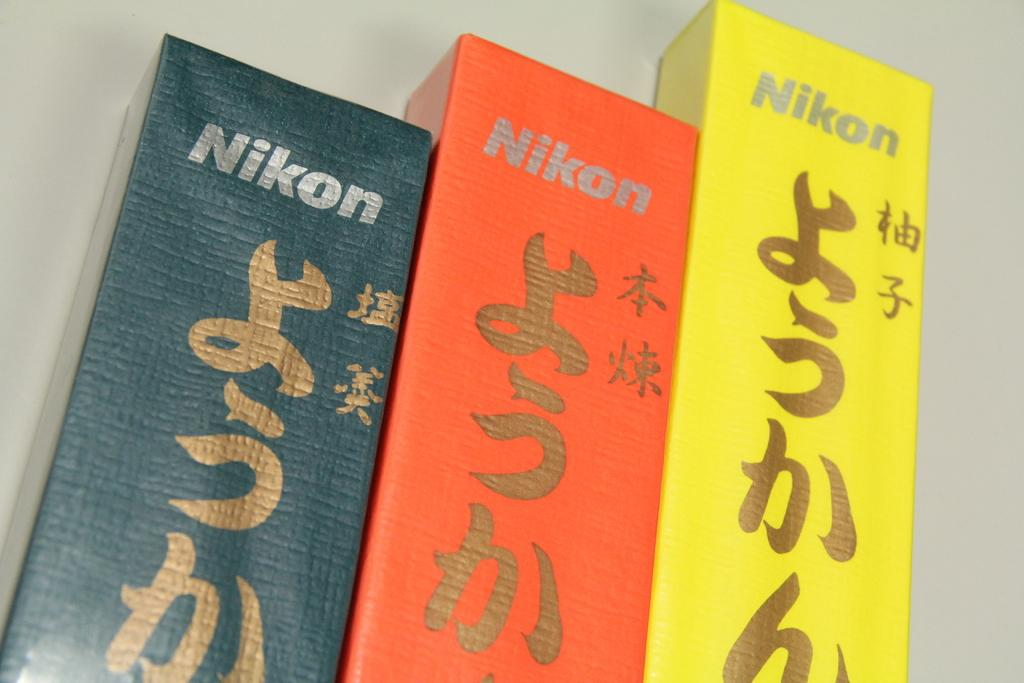Provide a one-sentence caption for the provided image. The three books with foreign writing are by Nikon. 